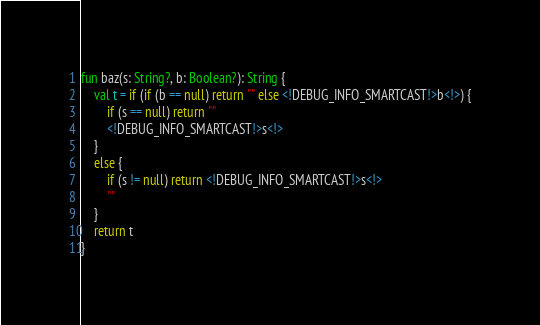Convert code to text. <code><loc_0><loc_0><loc_500><loc_500><_Kotlin_>fun baz(s: String?, b: Boolean?): String {
    val t = if (if (b == null) return "" else <!DEBUG_INFO_SMARTCAST!>b<!>) {
        if (s == null) return ""
        <!DEBUG_INFO_SMARTCAST!>s<!>
    }
    else {
        if (s != null) return <!DEBUG_INFO_SMARTCAST!>s<!>
        ""
    }
    return t
}</code> 